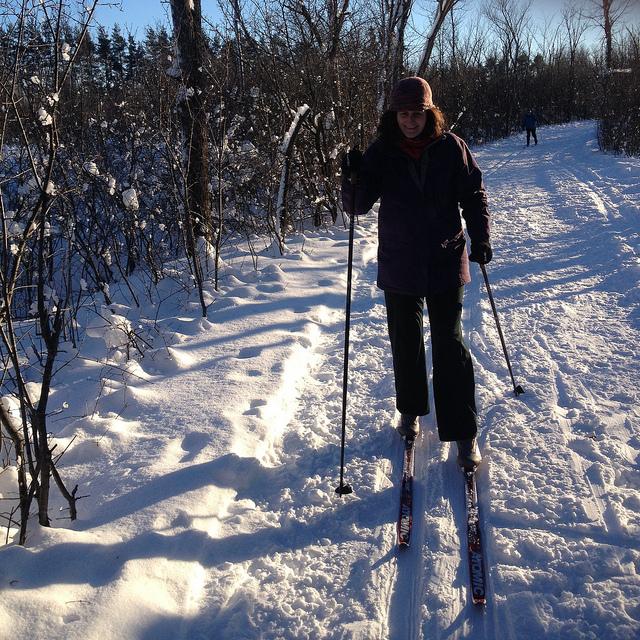What sport is the woman enjoying?
Answer briefly. Skiing. What kind of weather is this?
Answer briefly. Winter. What is on the woman's feet?
Answer briefly. Skis. 